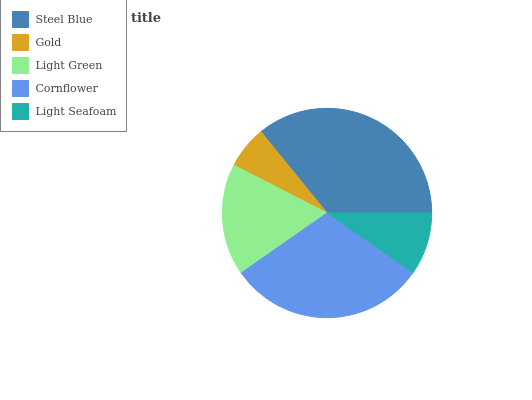Is Gold the minimum?
Answer yes or no. Yes. Is Steel Blue the maximum?
Answer yes or no. Yes. Is Light Green the minimum?
Answer yes or no. No. Is Light Green the maximum?
Answer yes or no. No. Is Light Green greater than Gold?
Answer yes or no. Yes. Is Gold less than Light Green?
Answer yes or no. Yes. Is Gold greater than Light Green?
Answer yes or no. No. Is Light Green less than Gold?
Answer yes or no. No. Is Light Green the high median?
Answer yes or no. Yes. Is Light Green the low median?
Answer yes or no. Yes. Is Steel Blue the high median?
Answer yes or no. No. Is Cornflower the low median?
Answer yes or no. No. 